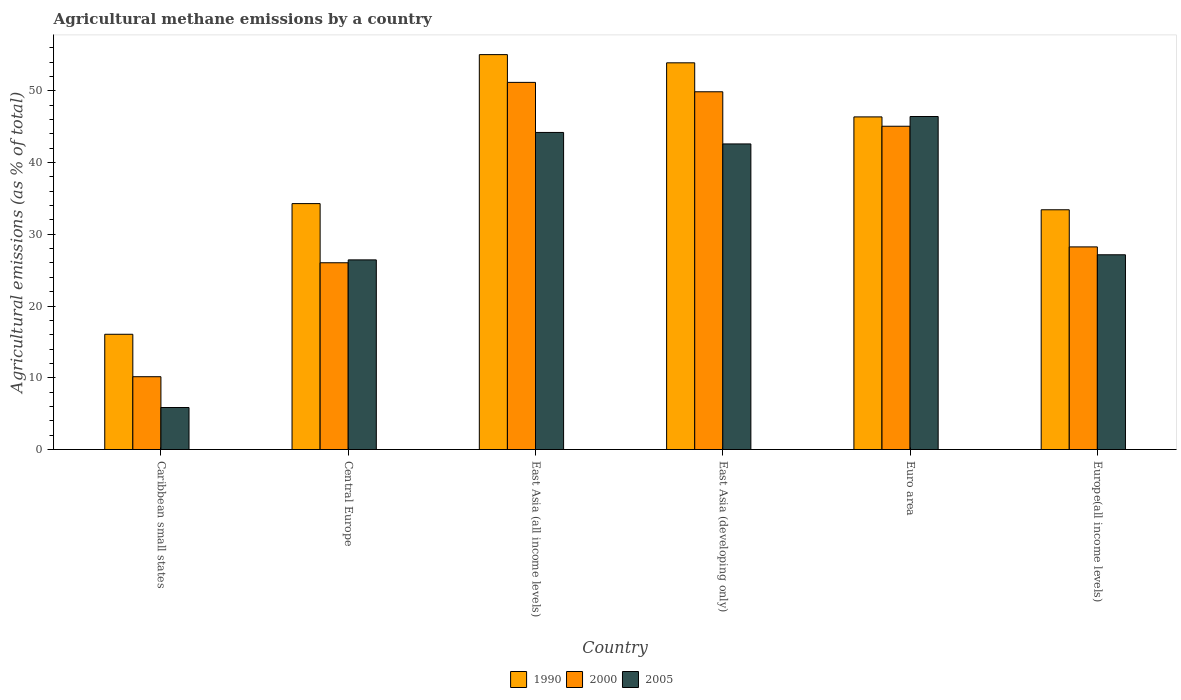How many different coloured bars are there?
Offer a terse response. 3. Are the number of bars per tick equal to the number of legend labels?
Ensure brevity in your answer.  Yes. Are the number of bars on each tick of the X-axis equal?
Keep it short and to the point. Yes. How many bars are there on the 4th tick from the left?
Offer a very short reply. 3. How many bars are there on the 4th tick from the right?
Offer a very short reply. 3. What is the label of the 6th group of bars from the left?
Provide a succinct answer. Europe(all income levels). What is the amount of agricultural methane emitted in 2005 in Euro area?
Keep it short and to the point. 46.41. Across all countries, what is the maximum amount of agricultural methane emitted in 2005?
Offer a very short reply. 46.41. Across all countries, what is the minimum amount of agricultural methane emitted in 2005?
Your response must be concise. 5.85. In which country was the amount of agricultural methane emitted in 1990 maximum?
Your answer should be compact. East Asia (all income levels). In which country was the amount of agricultural methane emitted in 2005 minimum?
Offer a terse response. Caribbean small states. What is the total amount of agricultural methane emitted in 2000 in the graph?
Give a very brief answer. 210.5. What is the difference between the amount of agricultural methane emitted in 2000 in Central Europe and that in East Asia (all income levels)?
Keep it short and to the point. -25.14. What is the difference between the amount of agricultural methane emitted in 1990 in East Asia (all income levels) and the amount of agricultural methane emitted in 2000 in East Asia (developing only)?
Make the answer very short. 5.18. What is the average amount of agricultural methane emitted in 2005 per country?
Provide a succinct answer. 32.1. What is the difference between the amount of agricultural methane emitted of/in 2000 and amount of agricultural methane emitted of/in 1990 in Caribbean small states?
Make the answer very short. -5.91. What is the ratio of the amount of agricultural methane emitted in 1990 in Central Europe to that in East Asia (all income levels)?
Provide a succinct answer. 0.62. What is the difference between the highest and the second highest amount of agricultural methane emitted in 1990?
Give a very brief answer. 7.54. What is the difference between the highest and the lowest amount of agricultural methane emitted in 1990?
Provide a short and direct response. 38.97. What does the 2nd bar from the right in Europe(all income levels) represents?
Provide a succinct answer. 2000. How many bars are there?
Your answer should be compact. 18. Are the values on the major ticks of Y-axis written in scientific E-notation?
Keep it short and to the point. No. Where does the legend appear in the graph?
Keep it short and to the point. Bottom center. How many legend labels are there?
Your answer should be compact. 3. What is the title of the graph?
Offer a terse response. Agricultural methane emissions by a country. Does "1970" appear as one of the legend labels in the graph?
Provide a succinct answer. No. What is the label or title of the Y-axis?
Provide a short and direct response. Agricultural emissions (as % of total). What is the Agricultural emissions (as % of total) in 1990 in Caribbean small states?
Keep it short and to the point. 16.06. What is the Agricultural emissions (as % of total) of 2000 in Caribbean small states?
Make the answer very short. 10.15. What is the Agricultural emissions (as % of total) in 2005 in Caribbean small states?
Ensure brevity in your answer.  5.85. What is the Agricultural emissions (as % of total) of 1990 in Central Europe?
Give a very brief answer. 34.27. What is the Agricultural emissions (as % of total) of 2000 in Central Europe?
Your answer should be very brief. 26.03. What is the Agricultural emissions (as % of total) of 2005 in Central Europe?
Your answer should be compact. 26.43. What is the Agricultural emissions (as % of total) in 1990 in East Asia (all income levels)?
Your answer should be compact. 55.04. What is the Agricultural emissions (as % of total) of 2000 in East Asia (all income levels)?
Give a very brief answer. 51.17. What is the Agricultural emissions (as % of total) of 2005 in East Asia (all income levels)?
Ensure brevity in your answer.  44.19. What is the Agricultural emissions (as % of total) of 1990 in East Asia (developing only)?
Your answer should be compact. 53.89. What is the Agricultural emissions (as % of total) of 2000 in East Asia (developing only)?
Your answer should be very brief. 49.86. What is the Agricultural emissions (as % of total) in 2005 in East Asia (developing only)?
Keep it short and to the point. 42.59. What is the Agricultural emissions (as % of total) in 1990 in Euro area?
Your response must be concise. 46.36. What is the Agricultural emissions (as % of total) of 2000 in Euro area?
Provide a short and direct response. 45.06. What is the Agricultural emissions (as % of total) in 2005 in Euro area?
Your response must be concise. 46.41. What is the Agricultural emissions (as % of total) in 1990 in Europe(all income levels)?
Your answer should be very brief. 33.41. What is the Agricultural emissions (as % of total) of 2000 in Europe(all income levels)?
Offer a very short reply. 28.24. What is the Agricultural emissions (as % of total) of 2005 in Europe(all income levels)?
Offer a very short reply. 27.14. Across all countries, what is the maximum Agricultural emissions (as % of total) in 1990?
Offer a very short reply. 55.04. Across all countries, what is the maximum Agricultural emissions (as % of total) in 2000?
Offer a very short reply. 51.17. Across all countries, what is the maximum Agricultural emissions (as % of total) in 2005?
Your answer should be compact. 46.41. Across all countries, what is the minimum Agricultural emissions (as % of total) in 1990?
Offer a terse response. 16.06. Across all countries, what is the minimum Agricultural emissions (as % of total) of 2000?
Ensure brevity in your answer.  10.15. Across all countries, what is the minimum Agricultural emissions (as % of total) in 2005?
Make the answer very short. 5.85. What is the total Agricultural emissions (as % of total) of 1990 in the graph?
Make the answer very short. 239.04. What is the total Agricultural emissions (as % of total) in 2000 in the graph?
Offer a terse response. 210.5. What is the total Agricultural emissions (as % of total) in 2005 in the graph?
Offer a terse response. 192.62. What is the difference between the Agricultural emissions (as % of total) in 1990 in Caribbean small states and that in Central Europe?
Your response must be concise. -18.21. What is the difference between the Agricultural emissions (as % of total) of 2000 in Caribbean small states and that in Central Europe?
Offer a terse response. -15.88. What is the difference between the Agricultural emissions (as % of total) of 2005 in Caribbean small states and that in Central Europe?
Make the answer very short. -20.58. What is the difference between the Agricultural emissions (as % of total) of 1990 in Caribbean small states and that in East Asia (all income levels)?
Give a very brief answer. -38.97. What is the difference between the Agricultural emissions (as % of total) in 2000 in Caribbean small states and that in East Asia (all income levels)?
Your response must be concise. -41.02. What is the difference between the Agricultural emissions (as % of total) in 2005 in Caribbean small states and that in East Asia (all income levels)?
Offer a terse response. -38.34. What is the difference between the Agricultural emissions (as % of total) of 1990 in Caribbean small states and that in East Asia (developing only)?
Provide a short and direct response. -37.83. What is the difference between the Agricultural emissions (as % of total) of 2000 in Caribbean small states and that in East Asia (developing only)?
Offer a terse response. -39.71. What is the difference between the Agricultural emissions (as % of total) of 2005 in Caribbean small states and that in East Asia (developing only)?
Give a very brief answer. -36.74. What is the difference between the Agricultural emissions (as % of total) in 1990 in Caribbean small states and that in Euro area?
Ensure brevity in your answer.  -30.29. What is the difference between the Agricultural emissions (as % of total) in 2000 in Caribbean small states and that in Euro area?
Keep it short and to the point. -34.91. What is the difference between the Agricultural emissions (as % of total) in 2005 in Caribbean small states and that in Euro area?
Ensure brevity in your answer.  -40.56. What is the difference between the Agricultural emissions (as % of total) in 1990 in Caribbean small states and that in Europe(all income levels)?
Provide a succinct answer. -17.35. What is the difference between the Agricultural emissions (as % of total) in 2000 in Caribbean small states and that in Europe(all income levels)?
Your answer should be compact. -18.09. What is the difference between the Agricultural emissions (as % of total) in 2005 in Caribbean small states and that in Europe(all income levels)?
Provide a succinct answer. -21.29. What is the difference between the Agricultural emissions (as % of total) in 1990 in Central Europe and that in East Asia (all income levels)?
Give a very brief answer. -20.76. What is the difference between the Agricultural emissions (as % of total) in 2000 in Central Europe and that in East Asia (all income levels)?
Your response must be concise. -25.14. What is the difference between the Agricultural emissions (as % of total) of 2005 in Central Europe and that in East Asia (all income levels)?
Your response must be concise. -17.76. What is the difference between the Agricultural emissions (as % of total) in 1990 in Central Europe and that in East Asia (developing only)?
Your answer should be compact. -19.62. What is the difference between the Agricultural emissions (as % of total) in 2000 in Central Europe and that in East Asia (developing only)?
Ensure brevity in your answer.  -23.83. What is the difference between the Agricultural emissions (as % of total) of 2005 in Central Europe and that in East Asia (developing only)?
Provide a succinct answer. -16.16. What is the difference between the Agricultural emissions (as % of total) of 1990 in Central Europe and that in Euro area?
Offer a very short reply. -12.08. What is the difference between the Agricultural emissions (as % of total) in 2000 in Central Europe and that in Euro area?
Your response must be concise. -19.03. What is the difference between the Agricultural emissions (as % of total) of 2005 in Central Europe and that in Euro area?
Make the answer very short. -19.98. What is the difference between the Agricultural emissions (as % of total) of 1990 in Central Europe and that in Europe(all income levels)?
Make the answer very short. 0.86. What is the difference between the Agricultural emissions (as % of total) of 2000 in Central Europe and that in Europe(all income levels)?
Give a very brief answer. -2.21. What is the difference between the Agricultural emissions (as % of total) of 2005 in Central Europe and that in Europe(all income levels)?
Offer a terse response. -0.71. What is the difference between the Agricultural emissions (as % of total) in 1990 in East Asia (all income levels) and that in East Asia (developing only)?
Offer a very short reply. 1.14. What is the difference between the Agricultural emissions (as % of total) in 2000 in East Asia (all income levels) and that in East Asia (developing only)?
Offer a very short reply. 1.31. What is the difference between the Agricultural emissions (as % of total) of 2005 in East Asia (all income levels) and that in East Asia (developing only)?
Keep it short and to the point. 1.6. What is the difference between the Agricultural emissions (as % of total) in 1990 in East Asia (all income levels) and that in Euro area?
Make the answer very short. 8.68. What is the difference between the Agricultural emissions (as % of total) of 2000 in East Asia (all income levels) and that in Euro area?
Offer a terse response. 6.11. What is the difference between the Agricultural emissions (as % of total) in 2005 in East Asia (all income levels) and that in Euro area?
Your response must be concise. -2.22. What is the difference between the Agricultural emissions (as % of total) of 1990 in East Asia (all income levels) and that in Europe(all income levels)?
Give a very brief answer. 21.62. What is the difference between the Agricultural emissions (as % of total) of 2000 in East Asia (all income levels) and that in Europe(all income levels)?
Ensure brevity in your answer.  22.93. What is the difference between the Agricultural emissions (as % of total) in 2005 in East Asia (all income levels) and that in Europe(all income levels)?
Provide a succinct answer. 17.05. What is the difference between the Agricultural emissions (as % of total) in 1990 in East Asia (developing only) and that in Euro area?
Your answer should be compact. 7.54. What is the difference between the Agricultural emissions (as % of total) of 2000 in East Asia (developing only) and that in Euro area?
Provide a succinct answer. 4.8. What is the difference between the Agricultural emissions (as % of total) in 2005 in East Asia (developing only) and that in Euro area?
Offer a very short reply. -3.82. What is the difference between the Agricultural emissions (as % of total) in 1990 in East Asia (developing only) and that in Europe(all income levels)?
Provide a short and direct response. 20.48. What is the difference between the Agricultural emissions (as % of total) in 2000 in East Asia (developing only) and that in Europe(all income levels)?
Give a very brief answer. 21.62. What is the difference between the Agricultural emissions (as % of total) of 2005 in East Asia (developing only) and that in Europe(all income levels)?
Offer a very short reply. 15.45. What is the difference between the Agricultural emissions (as % of total) of 1990 in Euro area and that in Europe(all income levels)?
Your answer should be very brief. 12.94. What is the difference between the Agricultural emissions (as % of total) in 2000 in Euro area and that in Europe(all income levels)?
Ensure brevity in your answer.  16.82. What is the difference between the Agricultural emissions (as % of total) of 2005 in Euro area and that in Europe(all income levels)?
Keep it short and to the point. 19.27. What is the difference between the Agricultural emissions (as % of total) of 1990 in Caribbean small states and the Agricultural emissions (as % of total) of 2000 in Central Europe?
Provide a succinct answer. -9.97. What is the difference between the Agricultural emissions (as % of total) in 1990 in Caribbean small states and the Agricultural emissions (as % of total) in 2005 in Central Europe?
Your answer should be compact. -10.37. What is the difference between the Agricultural emissions (as % of total) of 2000 in Caribbean small states and the Agricultural emissions (as % of total) of 2005 in Central Europe?
Offer a terse response. -16.28. What is the difference between the Agricultural emissions (as % of total) in 1990 in Caribbean small states and the Agricultural emissions (as % of total) in 2000 in East Asia (all income levels)?
Make the answer very short. -35.1. What is the difference between the Agricultural emissions (as % of total) in 1990 in Caribbean small states and the Agricultural emissions (as % of total) in 2005 in East Asia (all income levels)?
Ensure brevity in your answer.  -28.13. What is the difference between the Agricultural emissions (as % of total) in 2000 in Caribbean small states and the Agricultural emissions (as % of total) in 2005 in East Asia (all income levels)?
Ensure brevity in your answer.  -34.04. What is the difference between the Agricultural emissions (as % of total) in 1990 in Caribbean small states and the Agricultural emissions (as % of total) in 2000 in East Asia (developing only)?
Give a very brief answer. -33.8. What is the difference between the Agricultural emissions (as % of total) of 1990 in Caribbean small states and the Agricultural emissions (as % of total) of 2005 in East Asia (developing only)?
Give a very brief answer. -26.53. What is the difference between the Agricultural emissions (as % of total) in 2000 in Caribbean small states and the Agricultural emissions (as % of total) in 2005 in East Asia (developing only)?
Provide a succinct answer. -32.44. What is the difference between the Agricultural emissions (as % of total) of 1990 in Caribbean small states and the Agricultural emissions (as % of total) of 2000 in Euro area?
Keep it short and to the point. -28.99. What is the difference between the Agricultural emissions (as % of total) of 1990 in Caribbean small states and the Agricultural emissions (as % of total) of 2005 in Euro area?
Your answer should be compact. -30.35. What is the difference between the Agricultural emissions (as % of total) of 2000 in Caribbean small states and the Agricultural emissions (as % of total) of 2005 in Euro area?
Your answer should be very brief. -36.26. What is the difference between the Agricultural emissions (as % of total) of 1990 in Caribbean small states and the Agricultural emissions (as % of total) of 2000 in Europe(all income levels)?
Your response must be concise. -12.18. What is the difference between the Agricultural emissions (as % of total) in 1990 in Caribbean small states and the Agricultural emissions (as % of total) in 2005 in Europe(all income levels)?
Ensure brevity in your answer.  -11.08. What is the difference between the Agricultural emissions (as % of total) in 2000 in Caribbean small states and the Agricultural emissions (as % of total) in 2005 in Europe(all income levels)?
Keep it short and to the point. -16.99. What is the difference between the Agricultural emissions (as % of total) in 1990 in Central Europe and the Agricultural emissions (as % of total) in 2000 in East Asia (all income levels)?
Offer a terse response. -16.89. What is the difference between the Agricultural emissions (as % of total) in 1990 in Central Europe and the Agricultural emissions (as % of total) in 2005 in East Asia (all income levels)?
Provide a succinct answer. -9.92. What is the difference between the Agricultural emissions (as % of total) of 2000 in Central Europe and the Agricultural emissions (as % of total) of 2005 in East Asia (all income levels)?
Provide a succinct answer. -18.16. What is the difference between the Agricultural emissions (as % of total) of 1990 in Central Europe and the Agricultural emissions (as % of total) of 2000 in East Asia (developing only)?
Your answer should be compact. -15.59. What is the difference between the Agricultural emissions (as % of total) in 1990 in Central Europe and the Agricultural emissions (as % of total) in 2005 in East Asia (developing only)?
Make the answer very short. -8.32. What is the difference between the Agricultural emissions (as % of total) in 2000 in Central Europe and the Agricultural emissions (as % of total) in 2005 in East Asia (developing only)?
Your answer should be very brief. -16.56. What is the difference between the Agricultural emissions (as % of total) of 1990 in Central Europe and the Agricultural emissions (as % of total) of 2000 in Euro area?
Offer a very short reply. -10.78. What is the difference between the Agricultural emissions (as % of total) in 1990 in Central Europe and the Agricultural emissions (as % of total) in 2005 in Euro area?
Give a very brief answer. -12.14. What is the difference between the Agricultural emissions (as % of total) of 2000 in Central Europe and the Agricultural emissions (as % of total) of 2005 in Euro area?
Provide a succinct answer. -20.38. What is the difference between the Agricultural emissions (as % of total) in 1990 in Central Europe and the Agricultural emissions (as % of total) in 2000 in Europe(all income levels)?
Make the answer very short. 6.03. What is the difference between the Agricultural emissions (as % of total) of 1990 in Central Europe and the Agricultural emissions (as % of total) of 2005 in Europe(all income levels)?
Your answer should be very brief. 7.13. What is the difference between the Agricultural emissions (as % of total) in 2000 in Central Europe and the Agricultural emissions (as % of total) in 2005 in Europe(all income levels)?
Make the answer very short. -1.11. What is the difference between the Agricultural emissions (as % of total) of 1990 in East Asia (all income levels) and the Agricultural emissions (as % of total) of 2000 in East Asia (developing only)?
Provide a short and direct response. 5.18. What is the difference between the Agricultural emissions (as % of total) in 1990 in East Asia (all income levels) and the Agricultural emissions (as % of total) in 2005 in East Asia (developing only)?
Your response must be concise. 12.45. What is the difference between the Agricultural emissions (as % of total) in 2000 in East Asia (all income levels) and the Agricultural emissions (as % of total) in 2005 in East Asia (developing only)?
Provide a succinct answer. 8.58. What is the difference between the Agricultural emissions (as % of total) in 1990 in East Asia (all income levels) and the Agricultural emissions (as % of total) in 2000 in Euro area?
Give a very brief answer. 9.98. What is the difference between the Agricultural emissions (as % of total) of 1990 in East Asia (all income levels) and the Agricultural emissions (as % of total) of 2005 in Euro area?
Provide a short and direct response. 8.63. What is the difference between the Agricultural emissions (as % of total) in 2000 in East Asia (all income levels) and the Agricultural emissions (as % of total) in 2005 in Euro area?
Offer a terse response. 4.76. What is the difference between the Agricultural emissions (as % of total) in 1990 in East Asia (all income levels) and the Agricultural emissions (as % of total) in 2000 in Europe(all income levels)?
Your answer should be very brief. 26.8. What is the difference between the Agricultural emissions (as % of total) in 1990 in East Asia (all income levels) and the Agricultural emissions (as % of total) in 2005 in Europe(all income levels)?
Give a very brief answer. 27.9. What is the difference between the Agricultural emissions (as % of total) of 2000 in East Asia (all income levels) and the Agricultural emissions (as % of total) of 2005 in Europe(all income levels)?
Give a very brief answer. 24.03. What is the difference between the Agricultural emissions (as % of total) of 1990 in East Asia (developing only) and the Agricultural emissions (as % of total) of 2000 in Euro area?
Provide a short and direct response. 8.84. What is the difference between the Agricultural emissions (as % of total) in 1990 in East Asia (developing only) and the Agricultural emissions (as % of total) in 2005 in Euro area?
Offer a very short reply. 7.48. What is the difference between the Agricultural emissions (as % of total) of 2000 in East Asia (developing only) and the Agricultural emissions (as % of total) of 2005 in Euro area?
Your answer should be compact. 3.45. What is the difference between the Agricultural emissions (as % of total) in 1990 in East Asia (developing only) and the Agricultural emissions (as % of total) in 2000 in Europe(all income levels)?
Provide a succinct answer. 25.65. What is the difference between the Agricultural emissions (as % of total) in 1990 in East Asia (developing only) and the Agricultural emissions (as % of total) in 2005 in Europe(all income levels)?
Ensure brevity in your answer.  26.75. What is the difference between the Agricultural emissions (as % of total) of 2000 in East Asia (developing only) and the Agricultural emissions (as % of total) of 2005 in Europe(all income levels)?
Give a very brief answer. 22.72. What is the difference between the Agricultural emissions (as % of total) of 1990 in Euro area and the Agricultural emissions (as % of total) of 2000 in Europe(all income levels)?
Keep it short and to the point. 18.12. What is the difference between the Agricultural emissions (as % of total) of 1990 in Euro area and the Agricultural emissions (as % of total) of 2005 in Europe(all income levels)?
Keep it short and to the point. 19.22. What is the difference between the Agricultural emissions (as % of total) of 2000 in Euro area and the Agricultural emissions (as % of total) of 2005 in Europe(all income levels)?
Give a very brief answer. 17.91. What is the average Agricultural emissions (as % of total) in 1990 per country?
Your answer should be compact. 39.84. What is the average Agricultural emissions (as % of total) of 2000 per country?
Give a very brief answer. 35.08. What is the average Agricultural emissions (as % of total) in 2005 per country?
Ensure brevity in your answer.  32.1. What is the difference between the Agricultural emissions (as % of total) in 1990 and Agricultural emissions (as % of total) in 2000 in Caribbean small states?
Provide a short and direct response. 5.91. What is the difference between the Agricultural emissions (as % of total) in 1990 and Agricultural emissions (as % of total) in 2005 in Caribbean small states?
Your response must be concise. 10.21. What is the difference between the Agricultural emissions (as % of total) in 2000 and Agricultural emissions (as % of total) in 2005 in Caribbean small states?
Your answer should be compact. 4.29. What is the difference between the Agricultural emissions (as % of total) of 1990 and Agricultural emissions (as % of total) of 2000 in Central Europe?
Your response must be concise. 8.24. What is the difference between the Agricultural emissions (as % of total) of 1990 and Agricultural emissions (as % of total) of 2005 in Central Europe?
Your response must be concise. 7.84. What is the difference between the Agricultural emissions (as % of total) in 2000 and Agricultural emissions (as % of total) in 2005 in Central Europe?
Offer a terse response. -0.4. What is the difference between the Agricultural emissions (as % of total) of 1990 and Agricultural emissions (as % of total) of 2000 in East Asia (all income levels)?
Your response must be concise. 3.87. What is the difference between the Agricultural emissions (as % of total) of 1990 and Agricultural emissions (as % of total) of 2005 in East Asia (all income levels)?
Your answer should be very brief. 10.85. What is the difference between the Agricultural emissions (as % of total) of 2000 and Agricultural emissions (as % of total) of 2005 in East Asia (all income levels)?
Give a very brief answer. 6.98. What is the difference between the Agricultural emissions (as % of total) in 1990 and Agricultural emissions (as % of total) in 2000 in East Asia (developing only)?
Provide a succinct answer. 4.03. What is the difference between the Agricultural emissions (as % of total) in 1990 and Agricultural emissions (as % of total) in 2005 in East Asia (developing only)?
Ensure brevity in your answer.  11.3. What is the difference between the Agricultural emissions (as % of total) in 2000 and Agricultural emissions (as % of total) in 2005 in East Asia (developing only)?
Make the answer very short. 7.27. What is the difference between the Agricultural emissions (as % of total) of 1990 and Agricultural emissions (as % of total) of 2000 in Euro area?
Your answer should be compact. 1.3. What is the difference between the Agricultural emissions (as % of total) in 1990 and Agricultural emissions (as % of total) in 2005 in Euro area?
Your answer should be very brief. -0.05. What is the difference between the Agricultural emissions (as % of total) of 2000 and Agricultural emissions (as % of total) of 2005 in Euro area?
Provide a succinct answer. -1.36. What is the difference between the Agricultural emissions (as % of total) in 1990 and Agricultural emissions (as % of total) in 2000 in Europe(all income levels)?
Your answer should be compact. 5.17. What is the difference between the Agricultural emissions (as % of total) in 1990 and Agricultural emissions (as % of total) in 2005 in Europe(all income levels)?
Keep it short and to the point. 6.27. What is the difference between the Agricultural emissions (as % of total) of 2000 and Agricultural emissions (as % of total) of 2005 in Europe(all income levels)?
Your answer should be very brief. 1.1. What is the ratio of the Agricultural emissions (as % of total) in 1990 in Caribbean small states to that in Central Europe?
Provide a short and direct response. 0.47. What is the ratio of the Agricultural emissions (as % of total) of 2000 in Caribbean small states to that in Central Europe?
Your answer should be compact. 0.39. What is the ratio of the Agricultural emissions (as % of total) in 2005 in Caribbean small states to that in Central Europe?
Your answer should be compact. 0.22. What is the ratio of the Agricultural emissions (as % of total) of 1990 in Caribbean small states to that in East Asia (all income levels)?
Your answer should be very brief. 0.29. What is the ratio of the Agricultural emissions (as % of total) in 2000 in Caribbean small states to that in East Asia (all income levels)?
Give a very brief answer. 0.2. What is the ratio of the Agricultural emissions (as % of total) of 2005 in Caribbean small states to that in East Asia (all income levels)?
Your answer should be compact. 0.13. What is the ratio of the Agricultural emissions (as % of total) in 1990 in Caribbean small states to that in East Asia (developing only)?
Your answer should be very brief. 0.3. What is the ratio of the Agricultural emissions (as % of total) in 2000 in Caribbean small states to that in East Asia (developing only)?
Your response must be concise. 0.2. What is the ratio of the Agricultural emissions (as % of total) of 2005 in Caribbean small states to that in East Asia (developing only)?
Ensure brevity in your answer.  0.14. What is the ratio of the Agricultural emissions (as % of total) in 1990 in Caribbean small states to that in Euro area?
Keep it short and to the point. 0.35. What is the ratio of the Agricultural emissions (as % of total) in 2000 in Caribbean small states to that in Euro area?
Your answer should be very brief. 0.23. What is the ratio of the Agricultural emissions (as % of total) of 2005 in Caribbean small states to that in Euro area?
Provide a succinct answer. 0.13. What is the ratio of the Agricultural emissions (as % of total) in 1990 in Caribbean small states to that in Europe(all income levels)?
Your answer should be very brief. 0.48. What is the ratio of the Agricultural emissions (as % of total) of 2000 in Caribbean small states to that in Europe(all income levels)?
Provide a succinct answer. 0.36. What is the ratio of the Agricultural emissions (as % of total) of 2005 in Caribbean small states to that in Europe(all income levels)?
Keep it short and to the point. 0.22. What is the ratio of the Agricultural emissions (as % of total) in 1990 in Central Europe to that in East Asia (all income levels)?
Ensure brevity in your answer.  0.62. What is the ratio of the Agricultural emissions (as % of total) of 2000 in Central Europe to that in East Asia (all income levels)?
Your answer should be compact. 0.51. What is the ratio of the Agricultural emissions (as % of total) of 2005 in Central Europe to that in East Asia (all income levels)?
Your answer should be very brief. 0.6. What is the ratio of the Agricultural emissions (as % of total) in 1990 in Central Europe to that in East Asia (developing only)?
Your response must be concise. 0.64. What is the ratio of the Agricultural emissions (as % of total) in 2000 in Central Europe to that in East Asia (developing only)?
Make the answer very short. 0.52. What is the ratio of the Agricultural emissions (as % of total) in 2005 in Central Europe to that in East Asia (developing only)?
Your answer should be compact. 0.62. What is the ratio of the Agricultural emissions (as % of total) in 1990 in Central Europe to that in Euro area?
Provide a short and direct response. 0.74. What is the ratio of the Agricultural emissions (as % of total) in 2000 in Central Europe to that in Euro area?
Your answer should be very brief. 0.58. What is the ratio of the Agricultural emissions (as % of total) in 2005 in Central Europe to that in Euro area?
Your answer should be compact. 0.57. What is the ratio of the Agricultural emissions (as % of total) in 1990 in Central Europe to that in Europe(all income levels)?
Your answer should be compact. 1.03. What is the ratio of the Agricultural emissions (as % of total) of 2000 in Central Europe to that in Europe(all income levels)?
Ensure brevity in your answer.  0.92. What is the ratio of the Agricultural emissions (as % of total) in 2005 in Central Europe to that in Europe(all income levels)?
Provide a succinct answer. 0.97. What is the ratio of the Agricultural emissions (as % of total) in 1990 in East Asia (all income levels) to that in East Asia (developing only)?
Give a very brief answer. 1.02. What is the ratio of the Agricultural emissions (as % of total) of 2000 in East Asia (all income levels) to that in East Asia (developing only)?
Provide a short and direct response. 1.03. What is the ratio of the Agricultural emissions (as % of total) in 2005 in East Asia (all income levels) to that in East Asia (developing only)?
Your answer should be compact. 1.04. What is the ratio of the Agricultural emissions (as % of total) in 1990 in East Asia (all income levels) to that in Euro area?
Your answer should be compact. 1.19. What is the ratio of the Agricultural emissions (as % of total) of 2000 in East Asia (all income levels) to that in Euro area?
Your answer should be very brief. 1.14. What is the ratio of the Agricultural emissions (as % of total) of 2005 in East Asia (all income levels) to that in Euro area?
Offer a very short reply. 0.95. What is the ratio of the Agricultural emissions (as % of total) in 1990 in East Asia (all income levels) to that in Europe(all income levels)?
Ensure brevity in your answer.  1.65. What is the ratio of the Agricultural emissions (as % of total) of 2000 in East Asia (all income levels) to that in Europe(all income levels)?
Provide a short and direct response. 1.81. What is the ratio of the Agricultural emissions (as % of total) in 2005 in East Asia (all income levels) to that in Europe(all income levels)?
Your response must be concise. 1.63. What is the ratio of the Agricultural emissions (as % of total) of 1990 in East Asia (developing only) to that in Euro area?
Provide a succinct answer. 1.16. What is the ratio of the Agricultural emissions (as % of total) of 2000 in East Asia (developing only) to that in Euro area?
Keep it short and to the point. 1.11. What is the ratio of the Agricultural emissions (as % of total) in 2005 in East Asia (developing only) to that in Euro area?
Provide a succinct answer. 0.92. What is the ratio of the Agricultural emissions (as % of total) in 1990 in East Asia (developing only) to that in Europe(all income levels)?
Give a very brief answer. 1.61. What is the ratio of the Agricultural emissions (as % of total) in 2000 in East Asia (developing only) to that in Europe(all income levels)?
Offer a very short reply. 1.77. What is the ratio of the Agricultural emissions (as % of total) of 2005 in East Asia (developing only) to that in Europe(all income levels)?
Offer a terse response. 1.57. What is the ratio of the Agricultural emissions (as % of total) in 1990 in Euro area to that in Europe(all income levels)?
Ensure brevity in your answer.  1.39. What is the ratio of the Agricultural emissions (as % of total) in 2000 in Euro area to that in Europe(all income levels)?
Ensure brevity in your answer.  1.6. What is the ratio of the Agricultural emissions (as % of total) of 2005 in Euro area to that in Europe(all income levels)?
Provide a short and direct response. 1.71. What is the difference between the highest and the second highest Agricultural emissions (as % of total) of 1990?
Keep it short and to the point. 1.14. What is the difference between the highest and the second highest Agricultural emissions (as % of total) of 2000?
Keep it short and to the point. 1.31. What is the difference between the highest and the second highest Agricultural emissions (as % of total) in 2005?
Keep it short and to the point. 2.22. What is the difference between the highest and the lowest Agricultural emissions (as % of total) of 1990?
Offer a terse response. 38.97. What is the difference between the highest and the lowest Agricultural emissions (as % of total) in 2000?
Provide a short and direct response. 41.02. What is the difference between the highest and the lowest Agricultural emissions (as % of total) in 2005?
Offer a terse response. 40.56. 